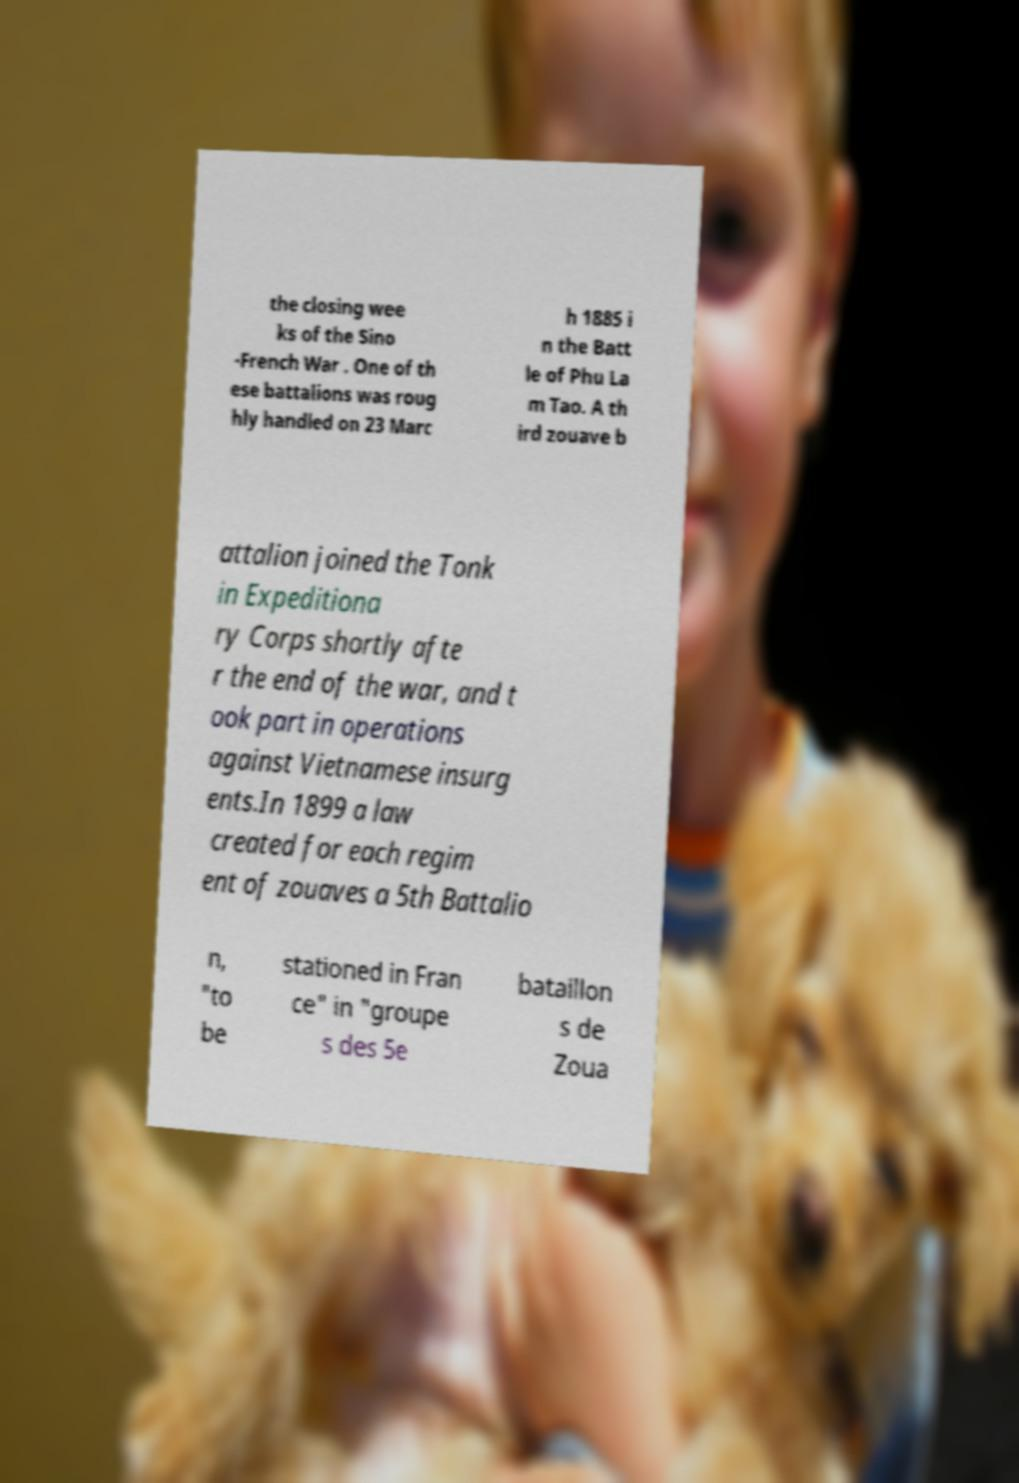Can you accurately transcribe the text from the provided image for me? the closing wee ks of the Sino -French War . One of th ese battalions was roug hly handled on 23 Marc h 1885 i n the Batt le of Phu La m Tao. A th ird zouave b attalion joined the Tonk in Expeditiona ry Corps shortly afte r the end of the war, and t ook part in operations against Vietnamese insurg ents.In 1899 a law created for each regim ent of zouaves a 5th Battalio n, "to be stationed in Fran ce" in "groupe s des 5e bataillon s de Zoua 